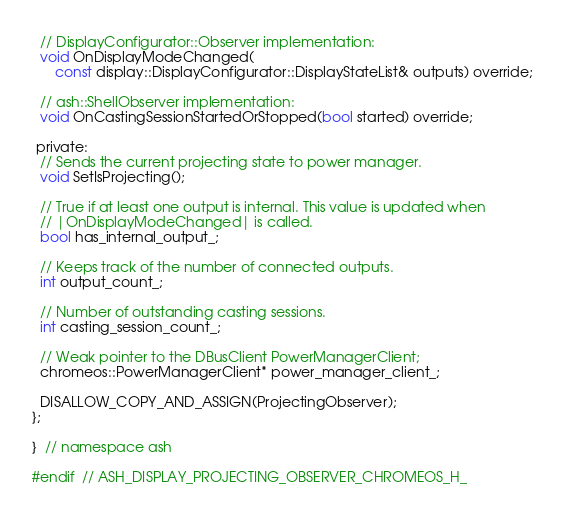Convert code to text. <code><loc_0><loc_0><loc_500><loc_500><_C_>  // DisplayConfigurator::Observer implementation:
  void OnDisplayModeChanged(
      const display::DisplayConfigurator::DisplayStateList& outputs) override;

  // ash::ShellObserver implementation:
  void OnCastingSessionStartedOrStopped(bool started) override;

 private:
  // Sends the current projecting state to power manager.
  void SetIsProjecting();

  // True if at least one output is internal. This value is updated when
  // |OnDisplayModeChanged| is called.
  bool has_internal_output_;

  // Keeps track of the number of connected outputs.
  int output_count_;

  // Number of outstanding casting sessions.
  int casting_session_count_;

  // Weak pointer to the DBusClient PowerManagerClient;
  chromeos::PowerManagerClient* power_manager_client_;

  DISALLOW_COPY_AND_ASSIGN(ProjectingObserver);
};

}  // namespace ash

#endif  // ASH_DISPLAY_PROJECTING_OBSERVER_CHROMEOS_H_
</code> 